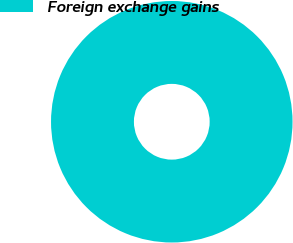Convert chart. <chart><loc_0><loc_0><loc_500><loc_500><pie_chart><fcel>Foreign exchange gains<nl><fcel>100.0%<nl></chart> 